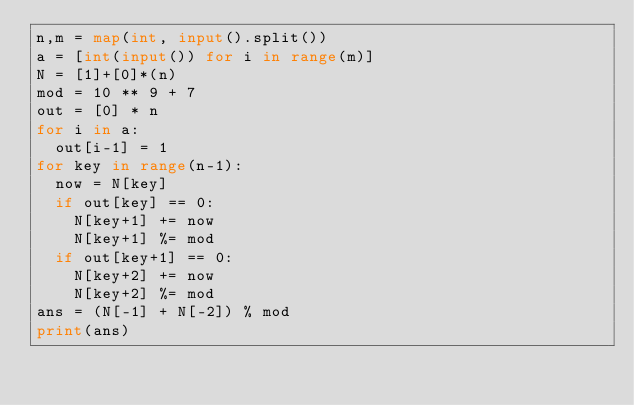<code> <loc_0><loc_0><loc_500><loc_500><_Python_>n,m = map(int, input().split())
a = [int(input()) for i in range(m)]
N = [1]+[0]*(n)
mod = 10 ** 9 + 7
out = [0] * n
for i in a:
  out[i-1] = 1
for key in range(n-1):
  now = N[key]
  if out[key] == 0:
    N[key+1] += now 
    N[key+1] %= mod
  if out[key+1] == 0:
    N[key+2] += now 
    N[key+2] %= mod
ans = (N[-1] + N[-2]) % mod
print(ans)
</code> 